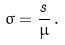<formula> <loc_0><loc_0><loc_500><loc_500>\sigma = \frac { s } { \mu } \, .</formula> 